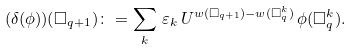<formula> <loc_0><loc_0><loc_500><loc_500>( \delta ( \phi ) ) ( \square _ { q + 1 } ) \colon = \sum _ { k } \, \varepsilon _ { k } \, U ^ { w ( \square _ { q + 1 } ) - w ( \square ^ { k } _ { q } ) } \, \phi ( \square ^ { k } _ { q } ) .</formula> 